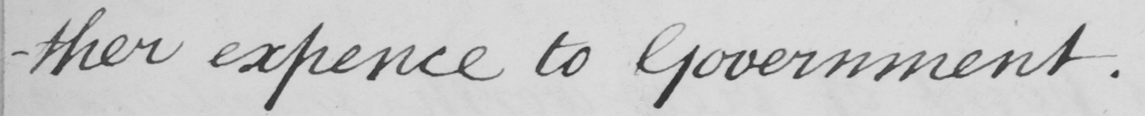What does this handwritten line say? -ther expence to Government 